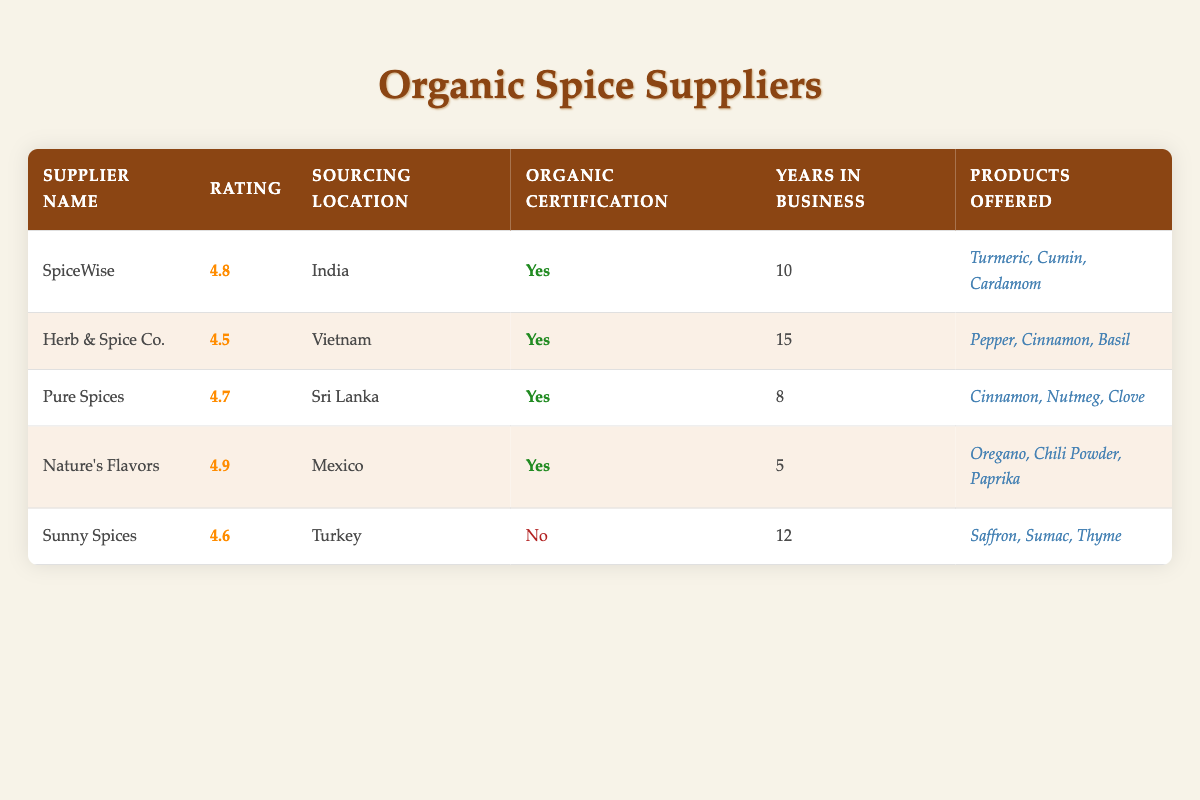What is the highest rating among the suppliers? By scanning the Rating column, we can see that "Nature's Flavors" has the highest rating of 4.9.
Answer: 4.9 How many years in business does "Herb & Spice Co." have? The Years in Business column shows that "Herb & Spice Co." has been in business for 15 years.
Answer: 15 Which suppliers are organic? We can determine organic certification by looking at the Organic Certification column. The suppliers that have organic certification marked as "Yes" are SpiceWise, Herb & Spice Co., Pure Spices, and Nature's Flavors.
Answer: SpiceWise, Herb & Spice Co., Pure Spices, Nature's Flavors What is the average rating of all suppliers? To calculate the average, we sum the ratings: (4.8 + 4.5 + 4.7 + 4.9 + 4.6) = 24.5, and since there are 5 suppliers, we divide: 24.5 / 5 = 4.9.
Answer: 4.9 Is it true that all suppliers from India have organic certification? Looking at the suppliers from the table, only "SpiceWise" from India has organic certification marked as "Yes." Since there is only one supplier listed from India, the statement holds true as it refers to the single entry.
Answer: Yes How many suppliers have more than 10 years in business and are certified organic? We check the Years in Business and Organic Certification columns. "SpiceWise" (10 years, organic) and "Herb & Spice Co." (15 years, organic) meet this criteria, making a total of 2 suppliers.
Answer: 2 What is the sourcing location of the supplier with the lowest rating? By looking for the lowest rating of 4.5, we find that "Herb & Spice Co." is the lowest-rated supplier and it is sourced from Vietnam.
Answer: Vietnam Which product is offered by "Pure Spices"? In the Products Offered column for "Pure Spices," it lists Cinnamon, Nutmeg, and Clove.
Answer: Cinnamon, Nutmeg, Clove How many suppliers are from Mexico or Turkey? The suppliers from Mexico and Turkey are "Nature's Flavors" from Mexico and "Sunny Spices" from Turkey. This gives us a total of 2 suppliers.
Answer: 2 